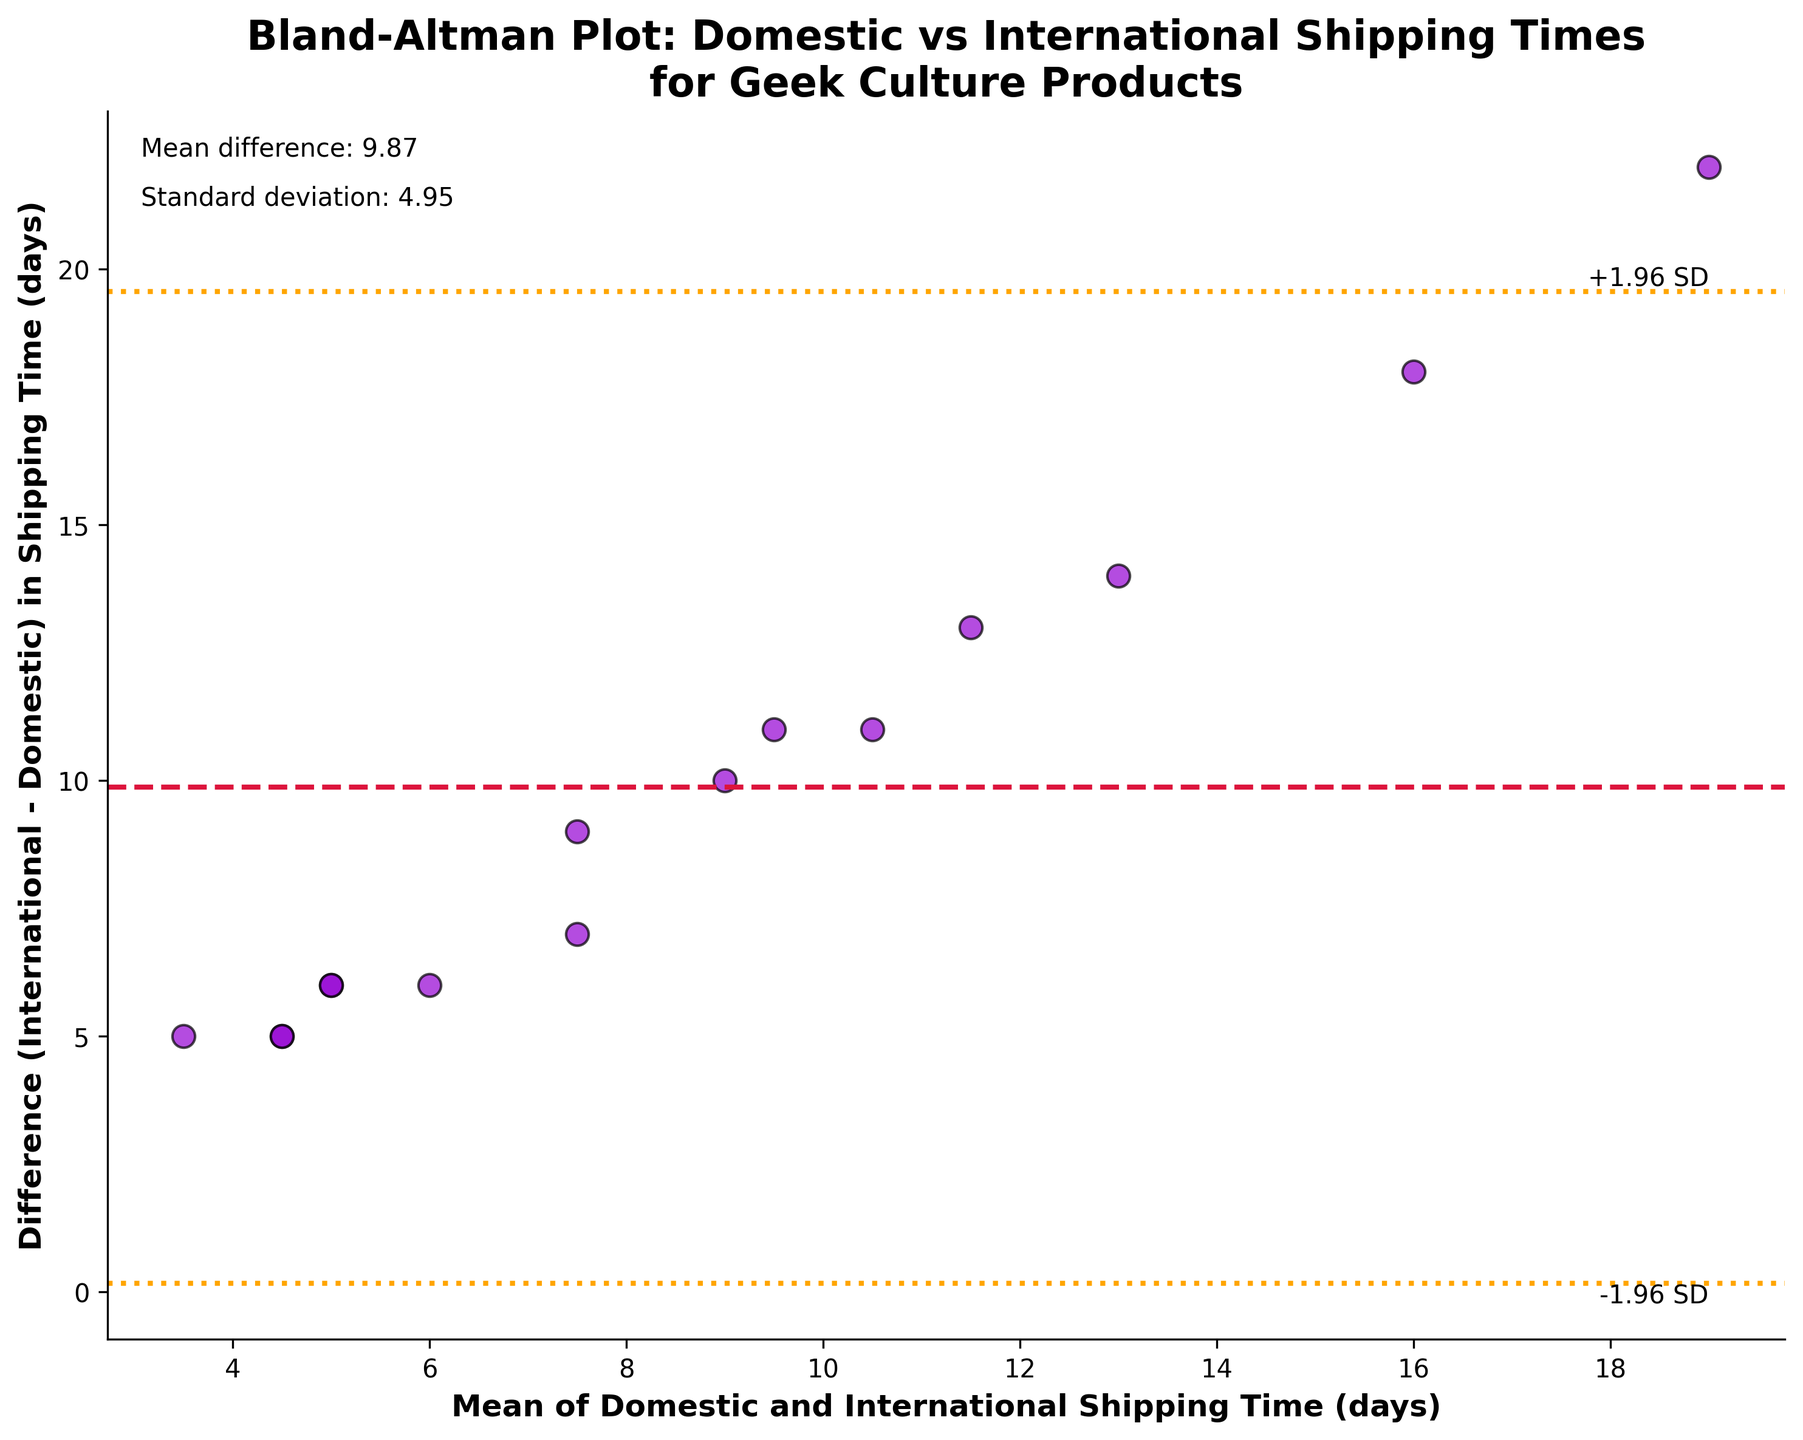What is the title of the plot? The title is located at the top of the plot and reads: "Bland-Altman Plot: Domestic vs International Shipping Times for Geek Culture Products".
Answer: Bland-Altman Plot: Domestic vs International Shipping Times for Geek Culture Products What are the x-axis and y-axis labels? The x-axis label, found below the horizontal axis, is "Mean of Domestic and International Shipping Time (days)". The y-axis label, found beside the vertical axis, is "Difference (International - Domestic) in Shipping Time (days)".
Answer: Mean of Domestic and International Shipping Time (days); Difference (International - Domestic) in Shipping Time (days) How many data points are there in the plot? Each point represents a pair of shipping times. Counting the points in the scatter plot, we find there are 15 data points.
Answer: 15 What is the mean difference in shipping time between domestic and international orders? The mean difference is shown with a text box at the top right of the plot and also marked by a horizontal dashed line. The value is given as 9.13 days.
Answer: 9.13 days What are the upper and lower limits of agreement in the plot? The plot shows two horizontal dotted lines representing the limits of agreement. They are labeled as "+1.96 SD" and "-1.96 SD". The y-values of these lines are indicated by text boxes and can be read from the plot. The upper limit is approximately 17.19 days and the lower limit is approximately 1.07 days.
Answer: 17.19 days (upper), 1.07 days (lower) Which data point has the largest difference in shipping times? By observing the vertical positions of the points relative to the y-axis, the highest point represents the largest difference. This corresponds to the shipping method "USPS Media Mail", which has a difference of 22 days.
Answer: USPS Media Mail What is the standard deviation of the differences in shipping time? The standard deviation is shown in a text box at the top right of the plot and it is noted as 4.10 days.
Answer: 4.10 days Which shipping method has the smallest difference in shipping times? By identifying the point closest to the x-axis (smallest y-value), the shipping method with the smallest difference is "USPS Express Mail" with a difference of 5 days.
Answer: USPS Express Mail How are the limits of agreement calculated? The limits of agreement are calculated as mean difference ± (1.96 times the standard deviation). Given the mean difference is 9.13 days and the standard deviation is 4.10 days: upper limit = 9.13 + (1.96 * 4.10); lower limit = 9.13 - (1.96 * 4.10).
Answer: Upper limit: 17.19 days, Lower limit: 1.07 days 